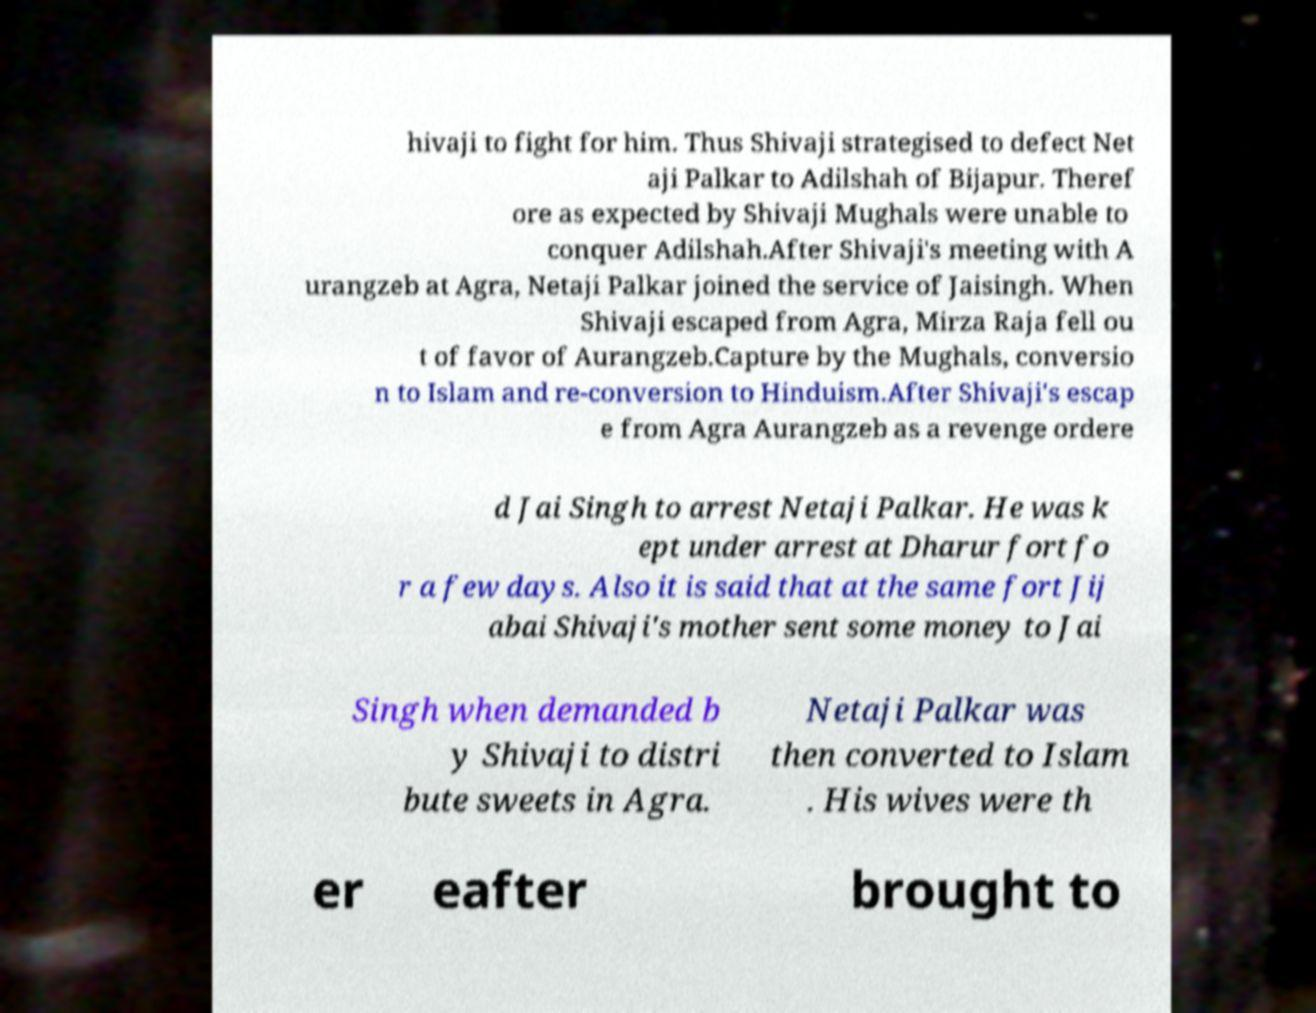Can you accurately transcribe the text from the provided image for me? hivaji to fight for him. Thus Shivaji strategised to defect Net aji Palkar to Adilshah of Bijapur. Theref ore as expected by Shivaji Mughals were unable to conquer Adilshah.After Shivaji's meeting with A urangzeb at Agra, Netaji Palkar joined the service of Jaisingh. When Shivaji escaped from Agra, Mirza Raja fell ou t of favor of Aurangzeb.Capture by the Mughals, conversio n to Islam and re-conversion to Hinduism.After Shivaji's escap e from Agra Aurangzeb as a revenge ordere d Jai Singh to arrest Netaji Palkar. He was k ept under arrest at Dharur fort fo r a few days. Also it is said that at the same fort Jij abai Shivaji's mother sent some money to Jai Singh when demanded b y Shivaji to distri bute sweets in Agra. Netaji Palkar was then converted to Islam . His wives were th er eafter brought to 